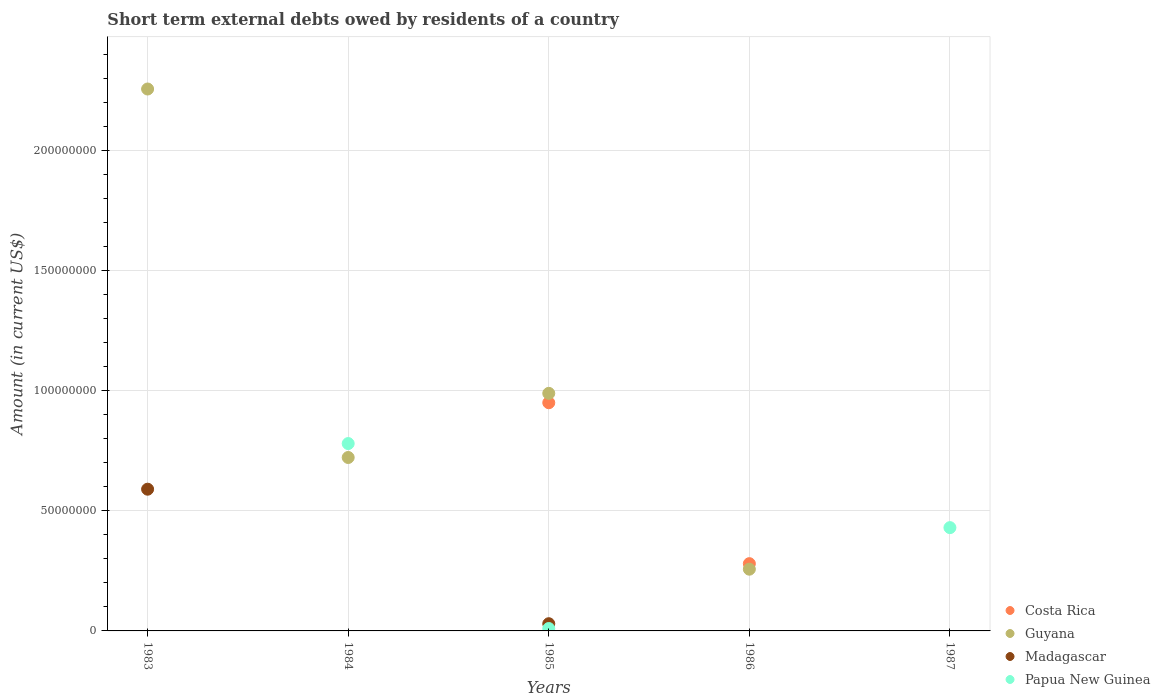How many different coloured dotlines are there?
Offer a very short reply. 4. Is the number of dotlines equal to the number of legend labels?
Provide a short and direct response. No. What is the amount of short-term external debts owed by residents in Madagascar in 1985?
Offer a very short reply. 3.00e+06. Across all years, what is the maximum amount of short-term external debts owed by residents in Costa Rica?
Give a very brief answer. 9.50e+07. Across all years, what is the minimum amount of short-term external debts owed by residents in Guyana?
Provide a short and direct response. 0. What is the total amount of short-term external debts owed by residents in Madagascar in the graph?
Make the answer very short. 6.20e+07. What is the difference between the amount of short-term external debts owed by residents in Guyana in 1983 and that in 1985?
Give a very brief answer. 1.27e+08. What is the difference between the amount of short-term external debts owed by residents in Costa Rica in 1986 and the amount of short-term external debts owed by residents in Guyana in 1987?
Your answer should be compact. 2.80e+07. What is the average amount of short-term external debts owed by residents in Costa Rica per year?
Make the answer very short. 2.46e+07. In the year 1985, what is the difference between the amount of short-term external debts owed by residents in Guyana and amount of short-term external debts owed by residents in Costa Rica?
Give a very brief answer. 3.90e+06. In how many years, is the amount of short-term external debts owed by residents in Madagascar greater than 180000000 US$?
Give a very brief answer. 0. What is the difference between the highest and the second highest amount of short-term external debts owed by residents in Papua New Guinea?
Provide a short and direct response. 3.50e+07. What is the difference between the highest and the lowest amount of short-term external debts owed by residents in Madagascar?
Your answer should be compact. 5.90e+07. In how many years, is the amount of short-term external debts owed by residents in Costa Rica greater than the average amount of short-term external debts owed by residents in Costa Rica taken over all years?
Your response must be concise. 2. Is it the case that in every year, the sum of the amount of short-term external debts owed by residents in Guyana and amount of short-term external debts owed by residents in Papua New Guinea  is greater than the amount of short-term external debts owed by residents in Costa Rica?
Your answer should be very brief. No. Is the amount of short-term external debts owed by residents in Madagascar strictly less than the amount of short-term external debts owed by residents in Guyana over the years?
Make the answer very short. No. How many dotlines are there?
Ensure brevity in your answer.  4. How many years are there in the graph?
Your answer should be very brief. 5. Are the values on the major ticks of Y-axis written in scientific E-notation?
Provide a succinct answer. No. Does the graph contain any zero values?
Ensure brevity in your answer.  Yes. Where does the legend appear in the graph?
Ensure brevity in your answer.  Bottom right. How many legend labels are there?
Ensure brevity in your answer.  4. What is the title of the graph?
Your response must be concise. Short term external debts owed by residents of a country. Does "Comoros" appear as one of the legend labels in the graph?
Make the answer very short. No. What is the label or title of the X-axis?
Give a very brief answer. Years. What is the Amount (in current US$) of Costa Rica in 1983?
Your response must be concise. 0. What is the Amount (in current US$) of Guyana in 1983?
Provide a short and direct response. 2.26e+08. What is the Amount (in current US$) in Madagascar in 1983?
Provide a short and direct response. 5.90e+07. What is the Amount (in current US$) of Costa Rica in 1984?
Your response must be concise. 0. What is the Amount (in current US$) in Guyana in 1984?
Provide a succinct answer. 7.22e+07. What is the Amount (in current US$) of Papua New Guinea in 1984?
Give a very brief answer. 7.80e+07. What is the Amount (in current US$) in Costa Rica in 1985?
Your answer should be compact. 9.50e+07. What is the Amount (in current US$) of Guyana in 1985?
Give a very brief answer. 9.89e+07. What is the Amount (in current US$) of Madagascar in 1985?
Offer a terse response. 3.00e+06. What is the Amount (in current US$) of Costa Rica in 1986?
Make the answer very short. 2.80e+07. What is the Amount (in current US$) in Guyana in 1986?
Offer a very short reply. 2.57e+07. What is the Amount (in current US$) in Costa Rica in 1987?
Keep it short and to the point. 0. What is the Amount (in current US$) in Madagascar in 1987?
Keep it short and to the point. 0. What is the Amount (in current US$) in Papua New Guinea in 1987?
Provide a short and direct response. 4.30e+07. Across all years, what is the maximum Amount (in current US$) in Costa Rica?
Make the answer very short. 9.50e+07. Across all years, what is the maximum Amount (in current US$) of Guyana?
Keep it short and to the point. 2.26e+08. Across all years, what is the maximum Amount (in current US$) of Madagascar?
Provide a short and direct response. 5.90e+07. Across all years, what is the maximum Amount (in current US$) in Papua New Guinea?
Your answer should be compact. 7.80e+07. Across all years, what is the minimum Amount (in current US$) of Costa Rica?
Offer a terse response. 0. Across all years, what is the minimum Amount (in current US$) in Guyana?
Keep it short and to the point. 0. Across all years, what is the minimum Amount (in current US$) in Papua New Guinea?
Keep it short and to the point. 0. What is the total Amount (in current US$) in Costa Rica in the graph?
Keep it short and to the point. 1.23e+08. What is the total Amount (in current US$) of Guyana in the graph?
Offer a terse response. 4.22e+08. What is the total Amount (in current US$) of Madagascar in the graph?
Your answer should be compact. 6.20e+07. What is the total Amount (in current US$) in Papua New Guinea in the graph?
Provide a succinct answer. 1.22e+08. What is the difference between the Amount (in current US$) in Guyana in 1983 and that in 1984?
Your answer should be compact. 1.53e+08. What is the difference between the Amount (in current US$) of Guyana in 1983 and that in 1985?
Offer a terse response. 1.27e+08. What is the difference between the Amount (in current US$) in Madagascar in 1983 and that in 1985?
Offer a very short reply. 5.60e+07. What is the difference between the Amount (in current US$) in Guyana in 1983 and that in 1986?
Keep it short and to the point. 2.00e+08. What is the difference between the Amount (in current US$) in Guyana in 1984 and that in 1985?
Make the answer very short. -2.67e+07. What is the difference between the Amount (in current US$) of Papua New Guinea in 1984 and that in 1985?
Provide a short and direct response. 7.70e+07. What is the difference between the Amount (in current US$) in Guyana in 1984 and that in 1986?
Provide a short and direct response. 4.65e+07. What is the difference between the Amount (in current US$) of Papua New Guinea in 1984 and that in 1987?
Make the answer very short. 3.50e+07. What is the difference between the Amount (in current US$) in Costa Rica in 1985 and that in 1986?
Offer a very short reply. 6.70e+07. What is the difference between the Amount (in current US$) of Guyana in 1985 and that in 1986?
Provide a short and direct response. 7.32e+07. What is the difference between the Amount (in current US$) in Papua New Guinea in 1985 and that in 1987?
Give a very brief answer. -4.20e+07. What is the difference between the Amount (in current US$) in Guyana in 1983 and the Amount (in current US$) in Papua New Guinea in 1984?
Your answer should be compact. 1.48e+08. What is the difference between the Amount (in current US$) in Madagascar in 1983 and the Amount (in current US$) in Papua New Guinea in 1984?
Your response must be concise. -1.90e+07. What is the difference between the Amount (in current US$) in Guyana in 1983 and the Amount (in current US$) in Madagascar in 1985?
Provide a succinct answer. 2.23e+08. What is the difference between the Amount (in current US$) in Guyana in 1983 and the Amount (in current US$) in Papua New Guinea in 1985?
Ensure brevity in your answer.  2.25e+08. What is the difference between the Amount (in current US$) of Madagascar in 1983 and the Amount (in current US$) of Papua New Guinea in 1985?
Ensure brevity in your answer.  5.80e+07. What is the difference between the Amount (in current US$) in Guyana in 1983 and the Amount (in current US$) in Papua New Guinea in 1987?
Your answer should be very brief. 1.83e+08. What is the difference between the Amount (in current US$) of Madagascar in 1983 and the Amount (in current US$) of Papua New Guinea in 1987?
Make the answer very short. 1.60e+07. What is the difference between the Amount (in current US$) in Guyana in 1984 and the Amount (in current US$) in Madagascar in 1985?
Your response must be concise. 6.92e+07. What is the difference between the Amount (in current US$) in Guyana in 1984 and the Amount (in current US$) in Papua New Guinea in 1985?
Keep it short and to the point. 7.12e+07. What is the difference between the Amount (in current US$) in Guyana in 1984 and the Amount (in current US$) in Papua New Guinea in 1987?
Your answer should be very brief. 2.92e+07. What is the difference between the Amount (in current US$) of Costa Rica in 1985 and the Amount (in current US$) of Guyana in 1986?
Your answer should be compact. 6.93e+07. What is the difference between the Amount (in current US$) in Costa Rica in 1985 and the Amount (in current US$) in Papua New Guinea in 1987?
Keep it short and to the point. 5.20e+07. What is the difference between the Amount (in current US$) of Guyana in 1985 and the Amount (in current US$) of Papua New Guinea in 1987?
Offer a terse response. 5.59e+07. What is the difference between the Amount (in current US$) of Madagascar in 1985 and the Amount (in current US$) of Papua New Guinea in 1987?
Ensure brevity in your answer.  -4.00e+07. What is the difference between the Amount (in current US$) in Costa Rica in 1986 and the Amount (in current US$) in Papua New Guinea in 1987?
Your answer should be very brief. -1.50e+07. What is the difference between the Amount (in current US$) in Guyana in 1986 and the Amount (in current US$) in Papua New Guinea in 1987?
Your answer should be compact. -1.73e+07. What is the average Amount (in current US$) in Costa Rica per year?
Provide a succinct answer. 2.46e+07. What is the average Amount (in current US$) of Guyana per year?
Provide a short and direct response. 8.45e+07. What is the average Amount (in current US$) in Madagascar per year?
Provide a short and direct response. 1.24e+07. What is the average Amount (in current US$) in Papua New Guinea per year?
Your answer should be compact. 2.44e+07. In the year 1983, what is the difference between the Amount (in current US$) in Guyana and Amount (in current US$) in Madagascar?
Your answer should be very brief. 1.67e+08. In the year 1984, what is the difference between the Amount (in current US$) in Guyana and Amount (in current US$) in Papua New Guinea?
Provide a short and direct response. -5.80e+06. In the year 1985, what is the difference between the Amount (in current US$) of Costa Rica and Amount (in current US$) of Guyana?
Your answer should be compact. -3.90e+06. In the year 1985, what is the difference between the Amount (in current US$) of Costa Rica and Amount (in current US$) of Madagascar?
Give a very brief answer. 9.20e+07. In the year 1985, what is the difference between the Amount (in current US$) in Costa Rica and Amount (in current US$) in Papua New Guinea?
Offer a very short reply. 9.40e+07. In the year 1985, what is the difference between the Amount (in current US$) in Guyana and Amount (in current US$) in Madagascar?
Provide a succinct answer. 9.59e+07. In the year 1985, what is the difference between the Amount (in current US$) of Guyana and Amount (in current US$) of Papua New Guinea?
Give a very brief answer. 9.79e+07. In the year 1985, what is the difference between the Amount (in current US$) of Madagascar and Amount (in current US$) of Papua New Guinea?
Your answer should be compact. 2.00e+06. In the year 1986, what is the difference between the Amount (in current US$) in Costa Rica and Amount (in current US$) in Guyana?
Provide a short and direct response. 2.30e+06. What is the ratio of the Amount (in current US$) in Guyana in 1983 to that in 1984?
Offer a very short reply. 3.12. What is the ratio of the Amount (in current US$) in Guyana in 1983 to that in 1985?
Keep it short and to the point. 2.28. What is the ratio of the Amount (in current US$) in Madagascar in 1983 to that in 1985?
Give a very brief answer. 19.67. What is the ratio of the Amount (in current US$) in Guyana in 1983 to that in 1986?
Your answer should be very brief. 8.78. What is the ratio of the Amount (in current US$) in Guyana in 1984 to that in 1985?
Make the answer very short. 0.73. What is the ratio of the Amount (in current US$) in Papua New Guinea in 1984 to that in 1985?
Your response must be concise. 78. What is the ratio of the Amount (in current US$) in Guyana in 1984 to that in 1986?
Offer a terse response. 2.81. What is the ratio of the Amount (in current US$) in Papua New Guinea in 1984 to that in 1987?
Give a very brief answer. 1.81. What is the ratio of the Amount (in current US$) of Costa Rica in 1985 to that in 1986?
Provide a succinct answer. 3.39. What is the ratio of the Amount (in current US$) of Guyana in 1985 to that in 1986?
Offer a very short reply. 3.85. What is the ratio of the Amount (in current US$) in Papua New Guinea in 1985 to that in 1987?
Your answer should be very brief. 0.02. What is the difference between the highest and the second highest Amount (in current US$) in Guyana?
Make the answer very short. 1.27e+08. What is the difference between the highest and the second highest Amount (in current US$) in Papua New Guinea?
Provide a succinct answer. 3.50e+07. What is the difference between the highest and the lowest Amount (in current US$) of Costa Rica?
Offer a terse response. 9.50e+07. What is the difference between the highest and the lowest Amount (in current US$) in Guyana?
Offer a very short reply. 2.26e+08. What is the difference between the highest and the lowest Amount (in current US$) in Madagascar?
Keep it short and to the point. 5.90e+07. What is the difference between the highest and the lowest Amount (in current US$) of Papua New Guinea?
Keep it short and to the point. 7.80e+07. 